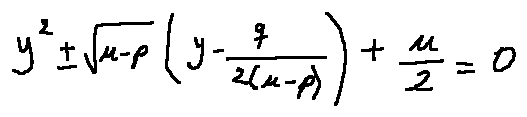Convert formula to latex. <formula><loc_0><loc_0><loc_500><loc_500>y ^ { 2 } \pm \sqrt { u - p } ( y - \frac { q } { 2 ( u - p ) } ) + \frac { u } { 2 } = 0</formula> 